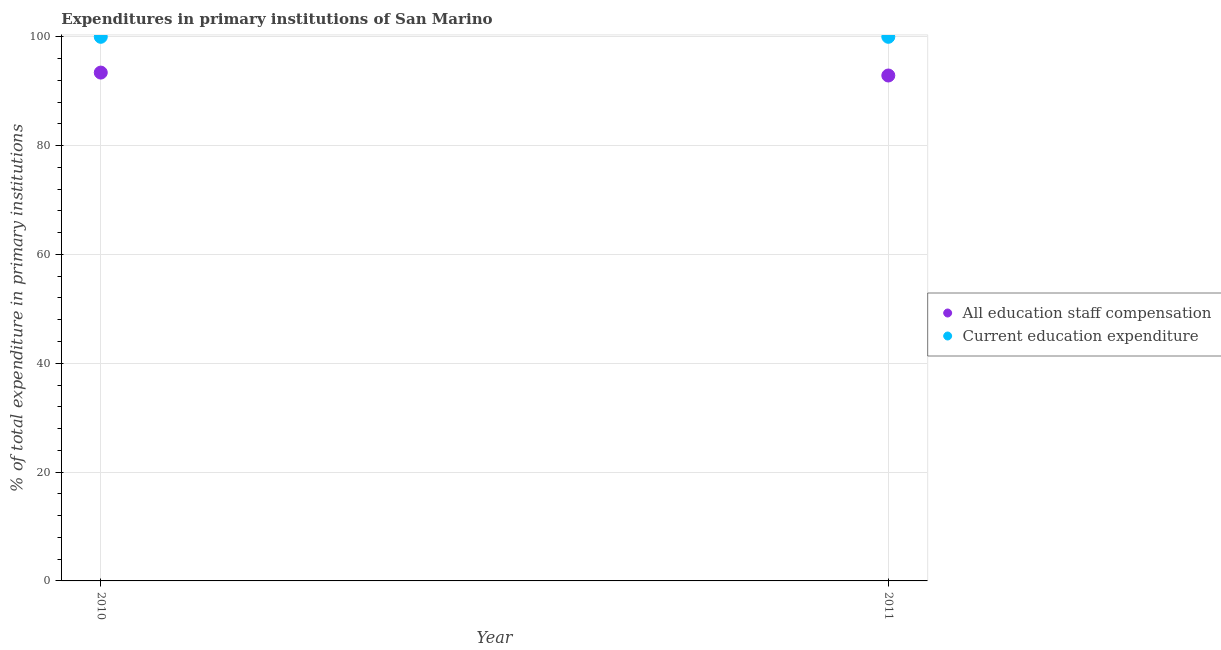Is the number of dotlines equal to the number of legend labels?
Your answer should be very brief. Yes. What is the expenditure in education in 2010?
Make the answer very short. 100. Across all years, what is the maximum expenditure in staff compensation?
Provide a succinct answer. 93.42. Across all years, what is the minimum expenditure in education?
Give a very brief answer. 100. In which year was the expenditure in staff compensation minimum?
Make the answer very short. 2011. What is the total expenditure in staff compensation in the graph?
Offer a terse response. 186.31. What is the difference between the expenditure in education in 2010 and that in 2011?
Your answer should be compact. 0. What is the difference between the expenditure in education in 2011 and the expenditure in staff compensation in 2010?
Your answer should be compact. 6.58. What is the average expenditure in staff compensation per year?
Give a very brief answer. 93.16. In the year 2010, what is the difference between the expenditure in staff compensation and expenditure in education?
Provide a short and direct response. -6.58. In how many years, is the expenditure in education greater than 16 %?
Give a very brief answer. 2. What is the ratio of the expenditure in education in 2010 to that in 2011?
Your answer should be very brief. 1. In how many years, is the expenditure in education greater than the average expenditure in education taken over all years?
Provide a succinct answer. 0. Does the expenditure in education monotonically increase over the years?
Your answer should be compact. No. Is the expenditure in education strictly greater than the expenditure in staff compensation over the years?
Provide a short and direct response. Yes. Is the expenditure in education strictly less than the expenditure in staff compensation over the years?
Ensure brevity in your answer.  No. How many years are there in the graph?
Ensure brevity in your answer.  2. Are the values on the major ticks of Y-axis written in scientific E-notation?
Give a very brief answer. No. How many legend labels are there?
Provide a succinct answer. 2. How are the legend labels stacked?
Provide a succinct answer. Vertical. What is the title of the graph?
Provide a succinct answer. Expenditures in primary institutions of San Marino. What is the label or title of the X-axis?
Offer a terse response. Year. What is the label or title of the Y-axis?
Your answer should be very brief. % of total expenditure in primary institutions. What is the % of total expenditure in primary institutions of All education staff compensation in 2010?
Your answer should be very brief. 93.42. What is the % of total expenditure in primary institutions in Current education expenditure in 2010?
Your response must be concise. 100. What is the % of total expenditure in primary institutions of All education staff compensation in 2011?
Your response must be concise. 92.89. Across all years, what is the maximum % of total expenditure in primary institutions in All education staff compensation?
Your response must be concise. 93.42. Across all years, what is the maximum % of total expenditure in primary institutions of Current education expenditure?
Your answer should be very brief. 100. Across all years, what is the minimum % of total expenditure in primary institutions in All education staff compensation?
Provide a short and direct response. 92.89. What is the total % of total expenditure in primary institutions of All education staff compensation in the graph?
Your answer should be compact. 186.31. What is the difference between the % of total expenditure in primary institutions of All education staff compensation in 2010 and that in 2011?
Offer a terse response. 0.54. What is the difference between the % of total expenditure in primary institutions of All education staff compensation in 2010 and the % of total expenditure in primary institutions of Current education expenditure in 2011?
Ensure brevity in your answer.  -6.58. What is the average % of total expenditure in primary institutions of All education staff compensation per year?
Offer a terse response. 93.16. In the year 2010, what is the difference between the % of total expenditure in primary institutions of All education staff compensation and % of total expenditure in primary institutions of Current education expenditure?
Your answer should be very brief. -6.58. In the year 2011, what is the difference between the % of total expenditure in primary institutions in All education staff compensation and % of total expenditure in primary institutions in Current education expenditure?
Ensure brevity in your answer.  -7.11. What is the difference between the highest and the second highest % of total expenditure in primary institutions of All education staff compensation?
Provide a short and direct response. 0.54. What is the difference between the highest and the second highest % of total expenditure in primary institutions in Current education expenditure?
Ensure brevity in your answer.  0. What is the difference between the highest and the lowest % of total expenditure in primary institutions in All education staff compensation?
Your response must be concise. 0.54. What is the difference between the highest and the lowest % of total expenditure in primary institutions of Current education expenditure?
Give a very brief answer. 0. 